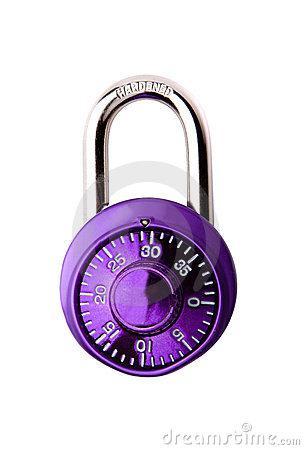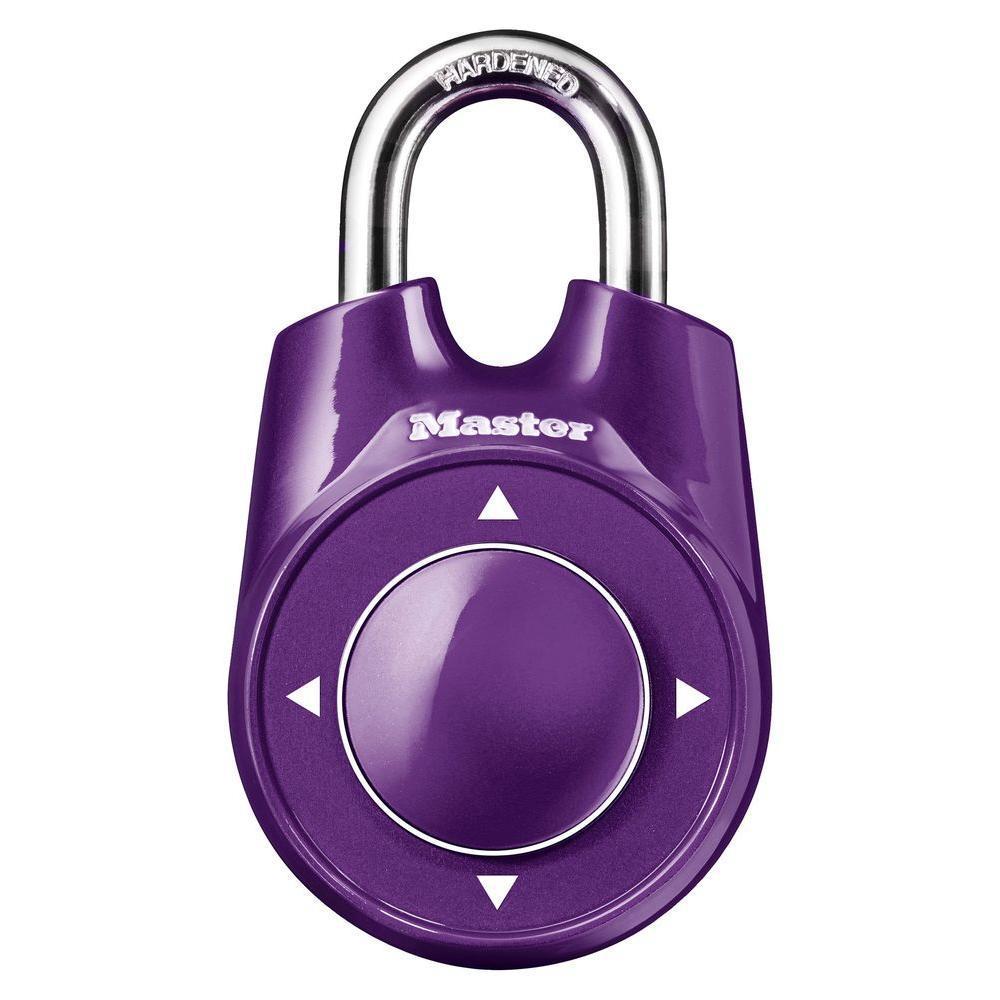The first image is the image on the left, the second image is the image on the right. Given the left and right images, does the statement "The lock in the left image has combination numbers on the bottom of the lock." hold true? Answer yes or no. No. The first image is the image on the left, the second image is the image on the right. Examine the images to the left and right. Is the description "There are two locks total and they are both the same color." accurate? Answer yes or no. Yes. 